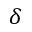<formula> <loc_0><loc_0><loc_500><loc_500>\delta</formula> 